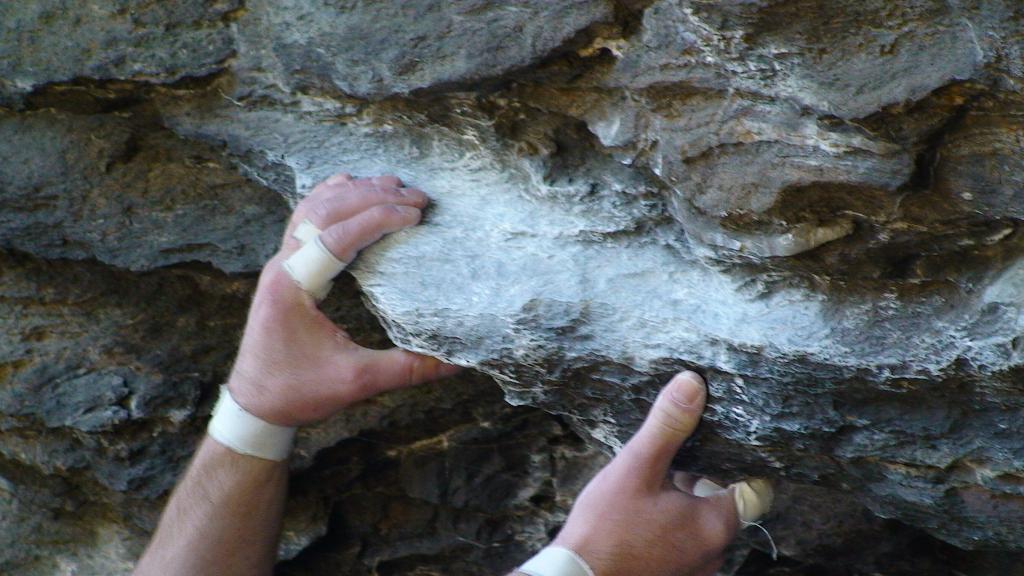Could you give a brief overview of what you see in this image? In this image I can see the person's hands and I can see the rock. 